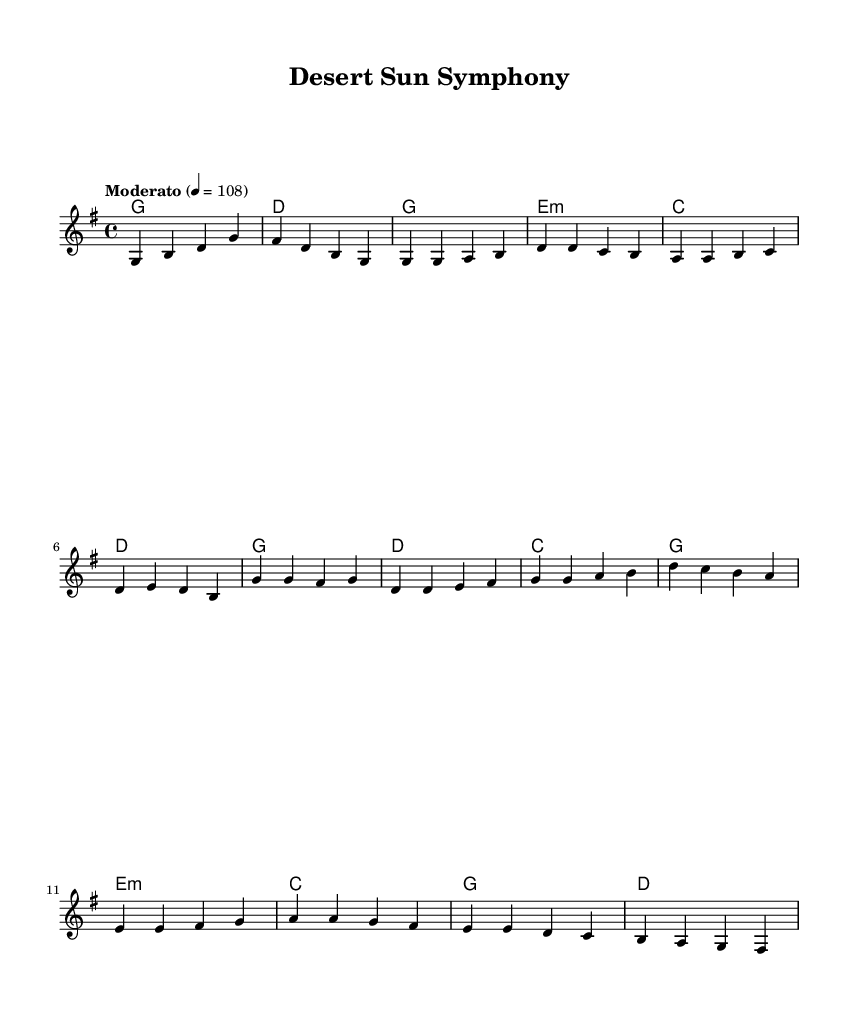What is the key signature of this music? The key signature is G major, which has one sharp (F#).
Answer: G major What is the time signature of this music? The time signature is 4/4, indicating four beats per measure.
Answer: 4/4 What is the tempo marking for this piece? The tempo marking indicates a moderate speed of 108 beats per minute.
Answer: Moderato, 108 How many measures are in the intro section? The intro consists of two measures, where the melody starts with G and transitions to D.
Answer: 2 Which chord is played during the chorus? The chorus includes the chords G, D, and C, alternating as specified in the harmonies.
Answer: G, D, C What is the distinctive feature of this composition relative to electronic music? This composition features a solar-powered synthesizer, focusing on themes of renewable energy and sustainability.
Answer: Solar-powered synthesizer What is the root note of the last chord in the bridge section? The last chord in the bridge is D minor, which has D as its root note.
Answer: D 